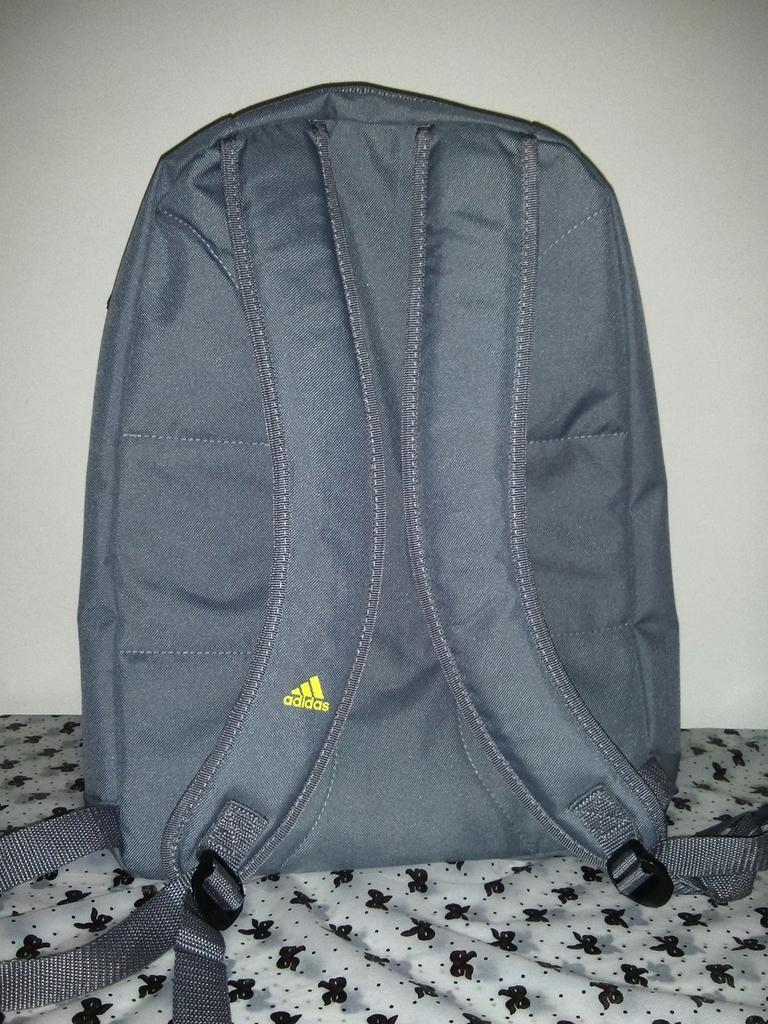<image>
Describe the image concisely. a backpack that says 'adidas' on it in yellow 